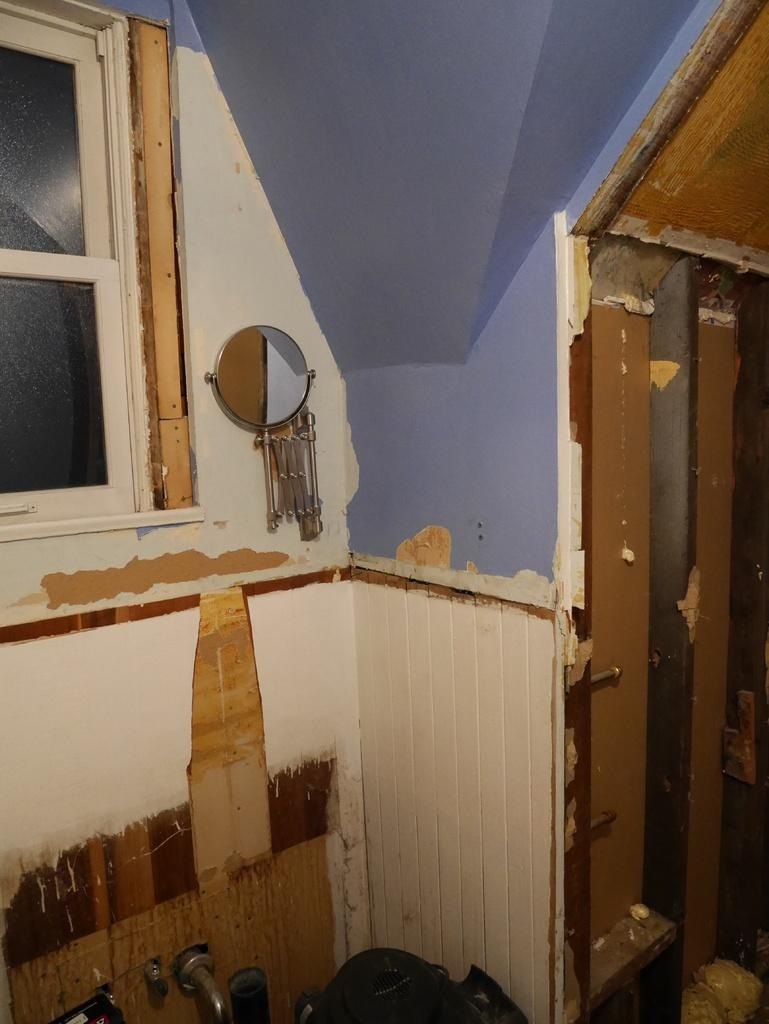What type of setting is shown in the image? The image depicts an inside view of a room. What is present on the wall in the room? There is a mirror on the wall in the room. Can you describe the windows in the room? There are windows in the room. What type of reaction can be seen from the boats in the image? There are no boats present in the image; it shows an inside view of a room with a mirror and windows. 